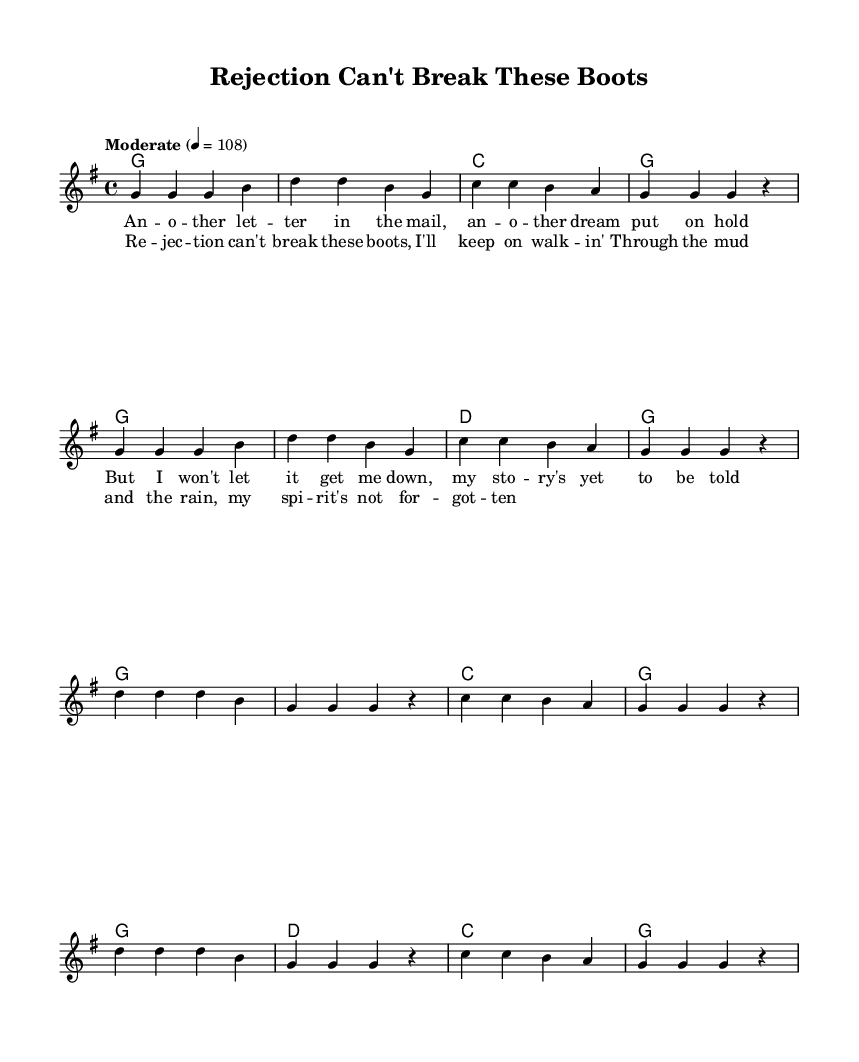What is the key signature of this music? The key signature is G major, which has one sharp (F#). This is indicated at the beginning of the music sheet, where the key signature is displayed.
Answer: G major What is the time signature of this music? The time signature is 4/4, which means there are four beats per measure. This is typically indicated at the beginning of the piece, right after the key signature.
Answer: 4/4 What is the tempo marking for this piece? The tempo marking is "Moderate", which guides the speed at which the piece should be played. It is indicated above the staff with beats per minute (4 = 108).
Answer: Moderate How many verses are included in the song? The song includes one verse, which can be identified by the repeated section of lyrics and melody in the sheet music. There are no additional verses indicated.
Answer: One What musical form does this song follow? The song follows a verse-chorus form, which is common in country music. This can be deduced from the structure where the verse is presented before the chorus.
Answer: Verse-chorus What is the starting note of the melody? The starting note of the melody is G, as seen at the beginning of the melody line where it first notes the pitch.
Answer: G What theme does the chorus convey? The chorus conveys the theme of resilience and determination in the face of rejection, typical in country music narratives. This can be inferred from the lyrics which emphasize that rejection won’t stop the singer.
Answer: Resilience 